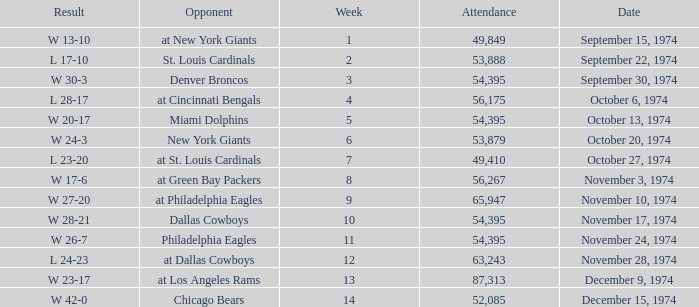What was the result of the game where 63,243 people attended after week 9? W 23-17. 